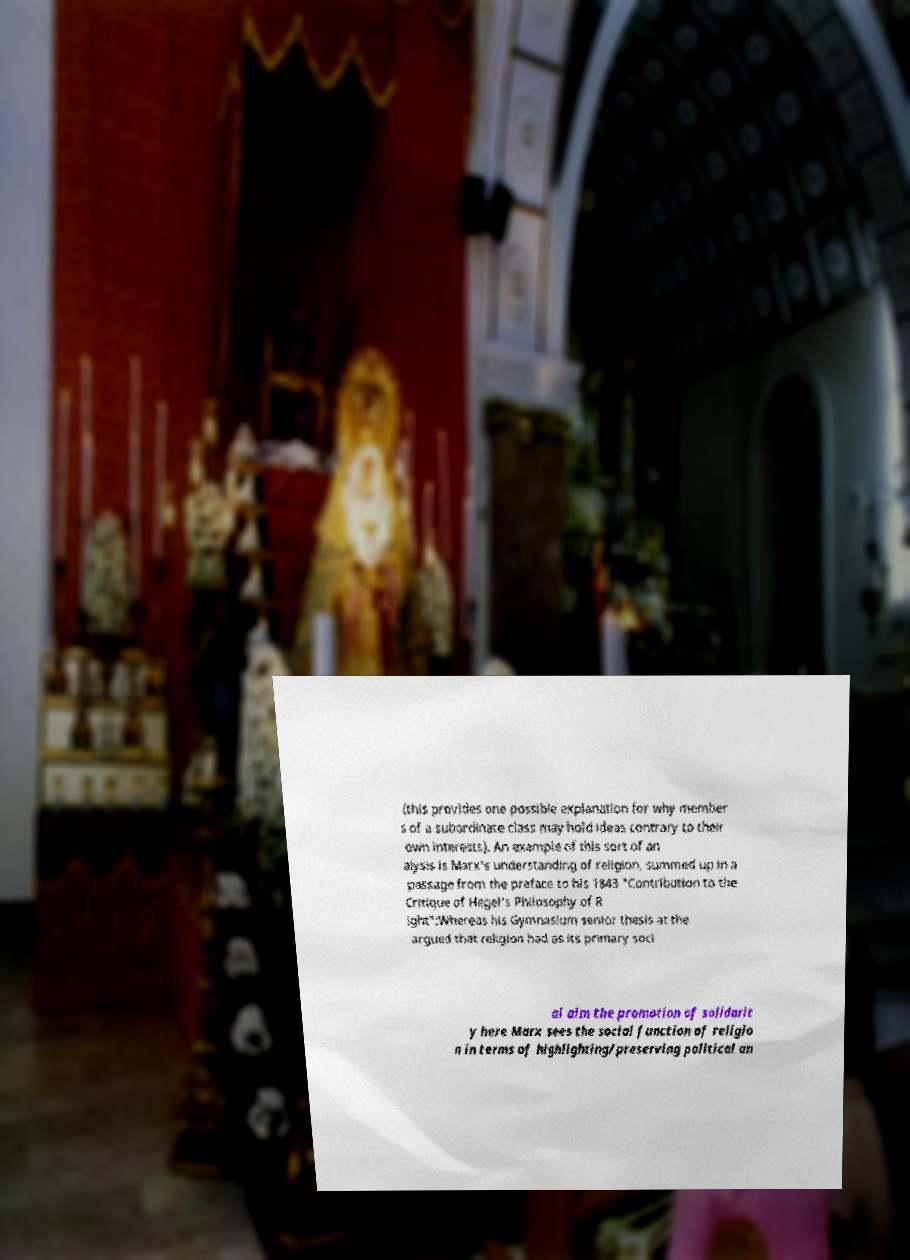There's text embedded in this image that I need extracted. Can you transcribe it verbatim? (this provides one possible explanation for why member s of a subordinate class may hold ideas contrary to their own interests). An example of this sort of an alysis is Marx's understanding of religion, summed up in a passage from the preface to his 1843 "Contribution to the Critique of Hegel's Philosophy of R ight":Whereas his Gymnasium senior thesis at the argued that religion had as its primary soci al aim the promotion of solidarit y here Marx sees the social function of religio n in terms of highlighting/preserving political an 